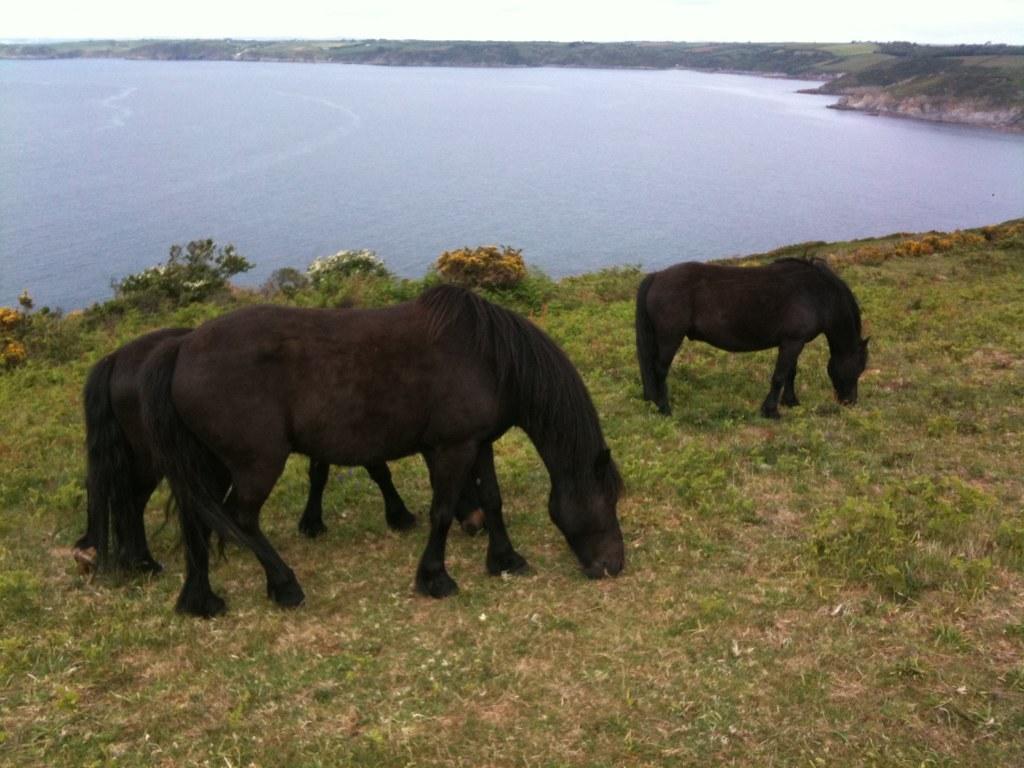Could you give a brief overview of what you see in this image? This picture contains three horses which are in black color are grazing in the field. At the bottom of the picture, we see the grass. Beside that, we see water and this water might be in the pond. There are trees in the background. 